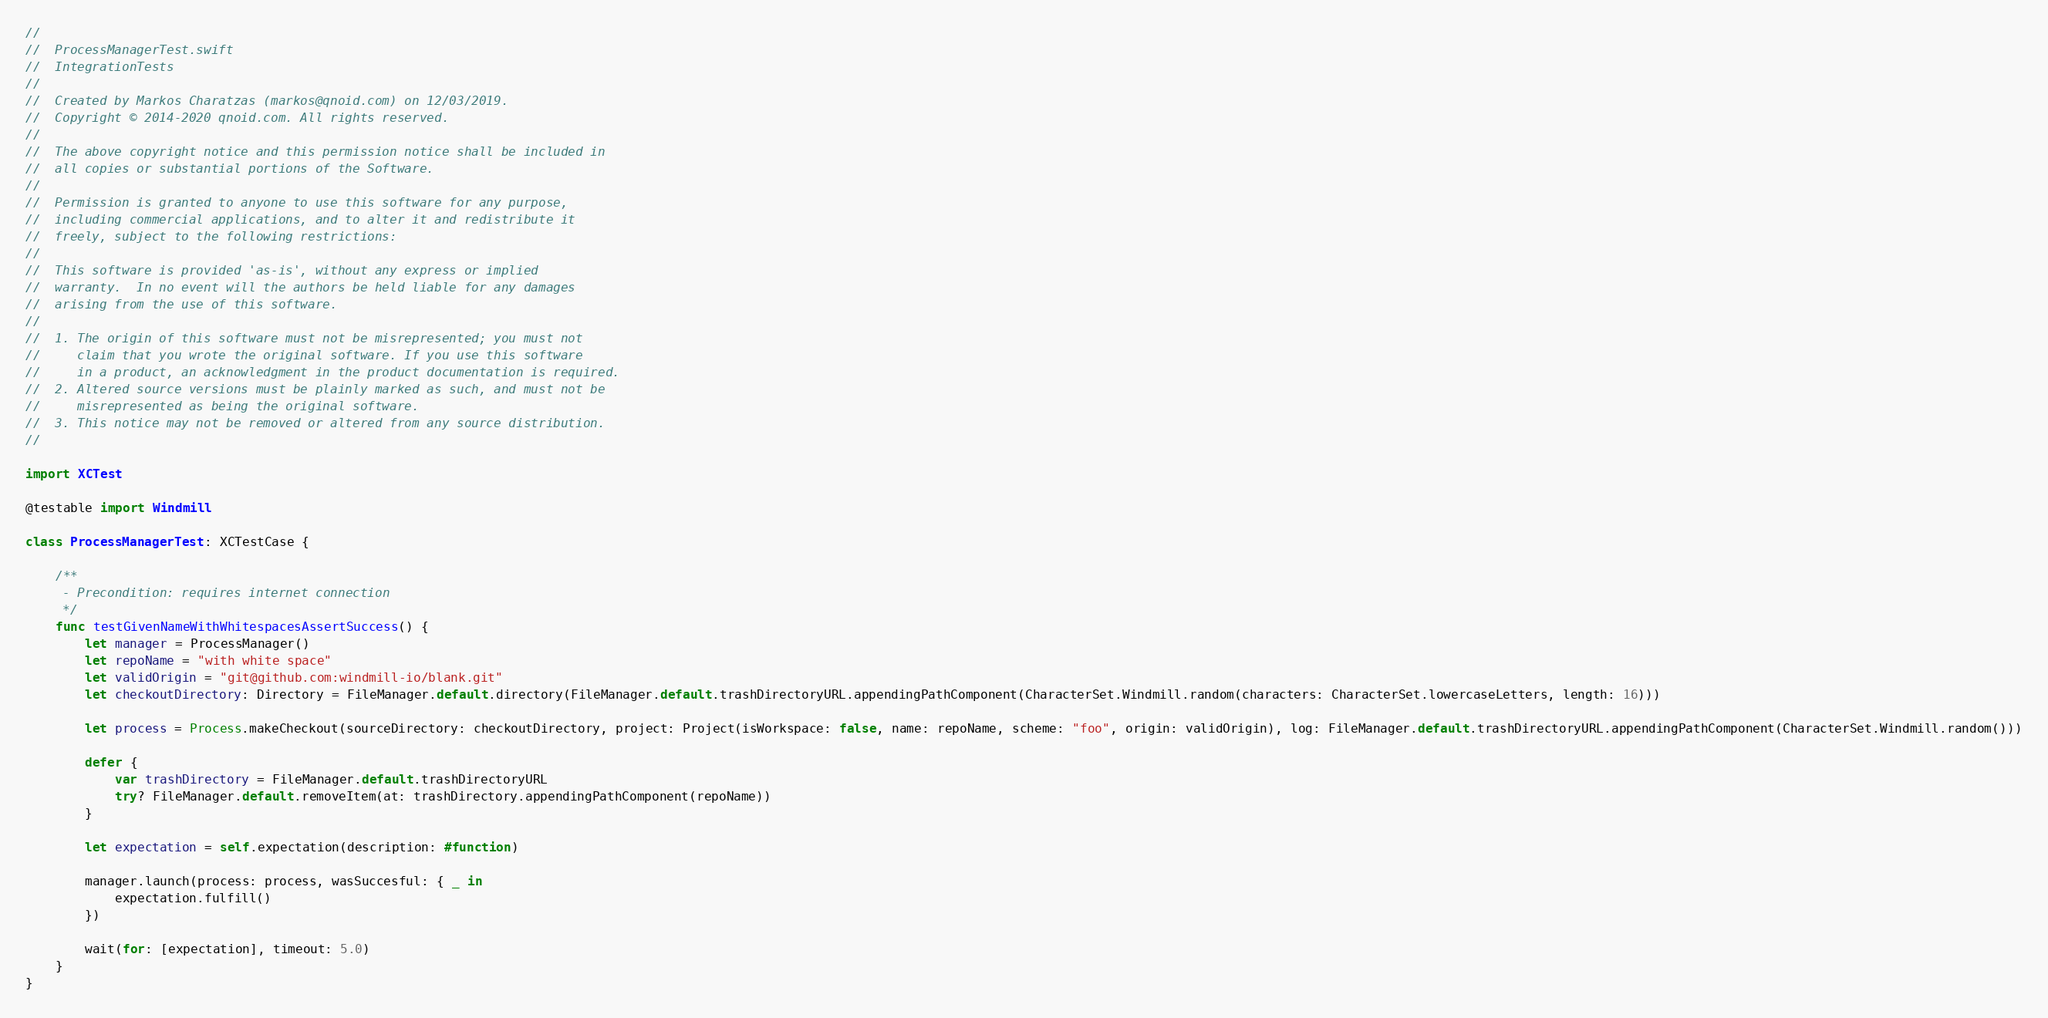<code> <loc_0><loc_0><loc_500><loc_500><_Swift_>//
//  ProcessManagerTest.swift
//  IntegrationTests
//
//  Created by Markos Charatzas (markos@qnoid.com) on 12/03/2019.
//  Copyright © 2014-2020 qnoid.com. All rights reserved.
//
//  The above copyright notice and this permission notice shall be included in
//  all copies or substantial portions of the Software.
//
//  Permission is granted to anyone to use this software for any purpose,
//  including commercial applications, and to alter it and redistribute it
//  freely, subject to the following restrictions:
//
//  This software is provided 'as-is', without any express or implied
//  warranty.  In no event will the authors be held liable for any damages
//  arising from the use of this software.
//
//  1. The origin of this software must not be misrepresented; you must not
//     claim that you wrote the original software. If you use this software
//     in a product, an acknowledgment in the product documentation is required.
//  2. Altered source versions must be plainly marked as such, and must not be
//     misrepresented as being the original software.
//  3. This notice may not be removed or altered from any source distribution.
//

import XCTest

@testable import Windmill

class ProcessManagerTest: XCTestCase {

    /**
     - Precondition: requires internet connection
     */
    func testGivenNameWithWhitespacesAssertSuccess() {
        let manager = ProcessManager()
        let repoName = "with white space"
        let validOrigin = "git@github.com:windmill-io/blank.git"
        let checkoutDirectory: Directory = FileManager.default.directory(FileManager.default.trashDirectoryURL.appendingPathComponent(CharacterSet.Windmill.random(characters: CharacterSet.lowercaseLetters, length: 16)))
        
        let process = Process.makeCheckout(sourceDirectory: checkoutDirectory, project: Project(isWorkspace: false, name: repoName, scheme: "foo", origin: validOrigin), log: FileManager.default.trashDirectoryURL.appendingPathComponent(CharacterSet.Windmill.random()))
        
        defer {
            var trashDirectory = FileManager.default.trashDirectoryURL
            try? FileManager.default.removeItem(at: trashDirectory.appendingPathComponent(repoName))
        }
        
        let expectation = self.expectation(description: #function)
        
        manager.launch(process: process, wasSuccesful: { _ in
            expectation.fulfill()
        })
        
        wait(for: [expectation], timeout: 5.0)
    }
}
</code> 